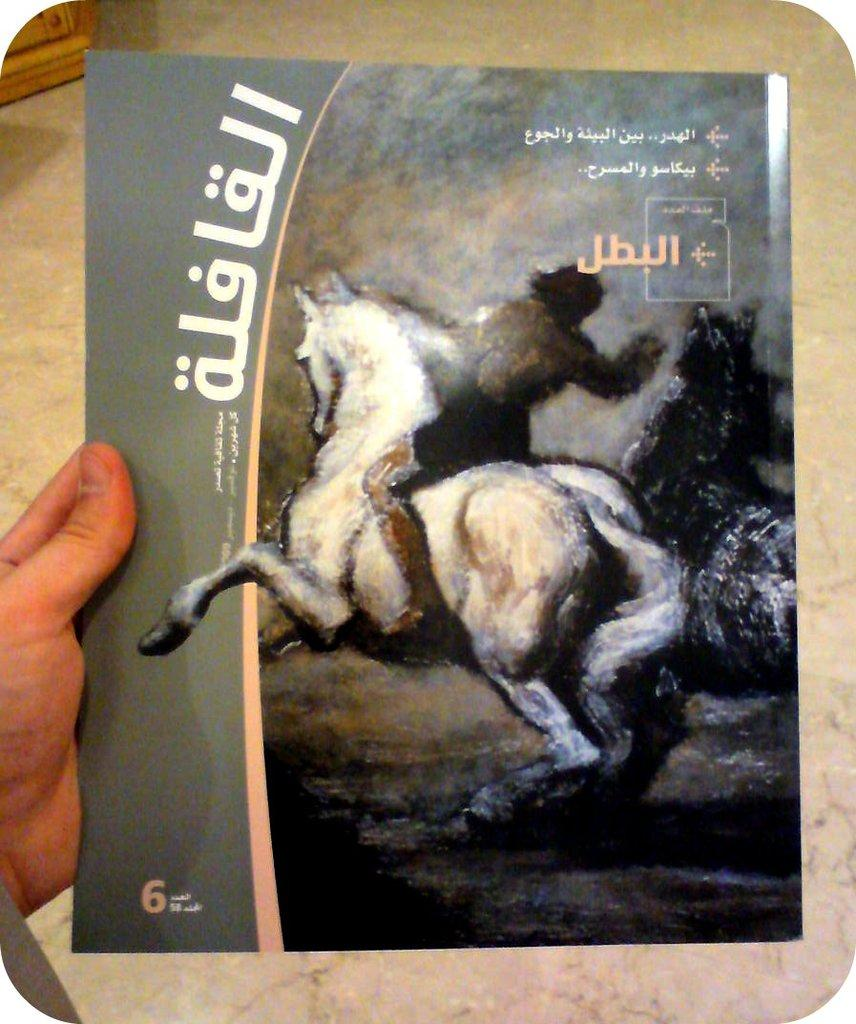<image>
Offer a succinct explanation of the picture presented. A book cover in a language that's not English has a number 6 on it. 